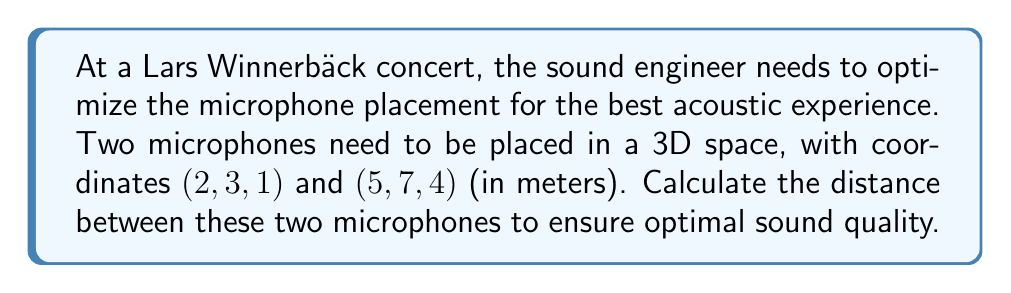Show me your answer to this math problem. To find the distance between two points in 3D space, we use the distance formula derived from the Pythagorean theorem:

$$d = \sqrt{(x_2 - x_1)^2 + (y_2 - y_1)^2 + (z_2 - z_1)^2}$$

Where $(x_1, y_1, z_1)$ are the coordinates of the first point and $(x_2, y_2, z_2)$ are the coordinates of the second point.

Let's substitute the given coordinates:
$(x_1, y_1, z_1) = (2, 3, 1)$
$(x_2, y_2, z_2) = (5, 7, 4)$

Now, let's calculate each term inside the square root:

1. $(x_2 - x_1)^2 = (5 - 2)^2 = 3^2 = 9$
2. $(y_2 - y_1)^2 = (7 - 3)^2 = 4^2 = 16$
3. $(z_2 - z_1)^2 = (4 - 1)^2 = 3^2 = 9$

Substituting these values into the formula:

$$d = \sqrt{9 + 16 + 9}$$
$$d = \sqrt{34}$$

The square root of 34 cannot be simplified further, so this is our final answer.
Answer: The distance between the two microphones is $\sqrt{34}$ meters. 